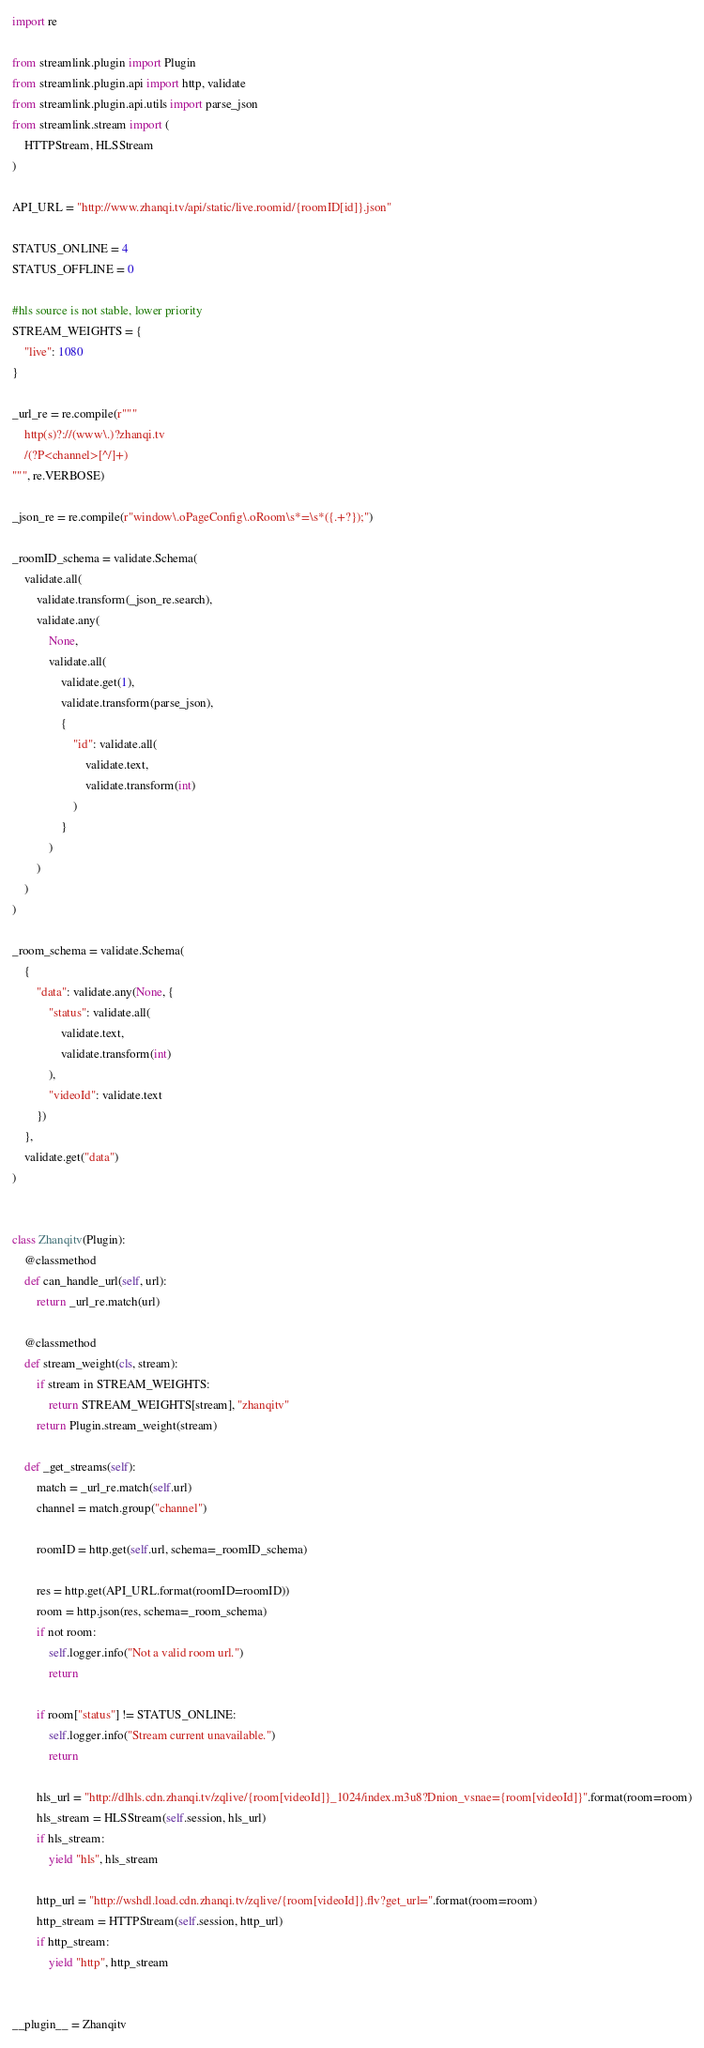<code> <loc_0><loc_0><loc_500><loc_500><_Python_>import re

from streamlink.plugin import Plugin
from streamlink.plugin.api import http, validate
from streamlink.plugin.api.utils import parse_json
from streamlink.stream import (
    HTTPStream, HLSStream
)

API_URL = "http://www.zhanqi.tv/api/static/live.roomid/{roomID[id]}.json"

STATUS_ONLINE = 4
STATUS_OFFLINE = 0

#hls source is not stable, lower priority
STREAM_WEIGHTS = {
    "live": 1080
}

_url_re = re.compile(r"""
    http(s)?://(www\.)?zhanqi.tv
    /(?P<channel>[^/]+)
""", re.VERBOSE)

_json_re = re.compile(r"window\.oPageConfig\.oRoom\s*=\s*({.+?});")

_roomID_schema = validate.Schema(
    validate.all(
        validate.transform(_json_re.search),
        validate.any(
            None,
            validate.all(
                validate.get(1),
                validate.transform(parse_json),
                {
                    "id": validate.all(
                        validate.text,
                        validate.transform(int)
                    )
                }
            )
        )
    )
)

_room_schema = validate.Schema(
    {
        "data": validate.any(None, {
            "status": validate.all(
                validate.text,
                validate.transform(int)
            ),
            "videoId": validate.text
        })
    },
    validate.get("data")
)


class Zhanqitv(Plugin):
    @classmethod
    def can_handle_url(self, url):
        return _url_re.match(url)

    @classmethod
    def stream_weight(cls, stream):
        if stream in STREAM_WEIGHTS:
            return STREAM_WEIGHTS[stream], "zhanqitv"
        return Plugin.stream_weight(stream)

    def _get_streams(self):
        match = _url_re.match(self.url)
        channel = match.group("channel")

        roomID = http.get(self.url, schema=_roomID_schema)

        res = http.get(API_URL.format(roomID=roomID))
        room = http.json(res, schema=_room_schema)
        if not room:
            self.logger.info("Not a valid room url.")
            return

        if room["status"] != STATUS_ONLINE:
            self.logger.info("Stream current unavailable.")
            return

        hls_url = "http://dlhls.cdn.zhanqi.tv/zqlive/{room[videoId]}_1024/index.m3u8?Dnion_vsnae={room[videoId]}".format(room=room)
        hls_stream = HLSStream(self.session, hls_url)
        if hls_stream:
            yield "hls", hls_stream

        http_url = "http://wshdl.load.cdn.zhanqi.tv/zqlive/{room[videoId]}.flv?get_url=".format(room=room)
        http_stream = HTTPStream(self.session, http_url)
        if http_stream:
            yield "http", http_stream


__plugin__ = Zhanqitv
</code> 